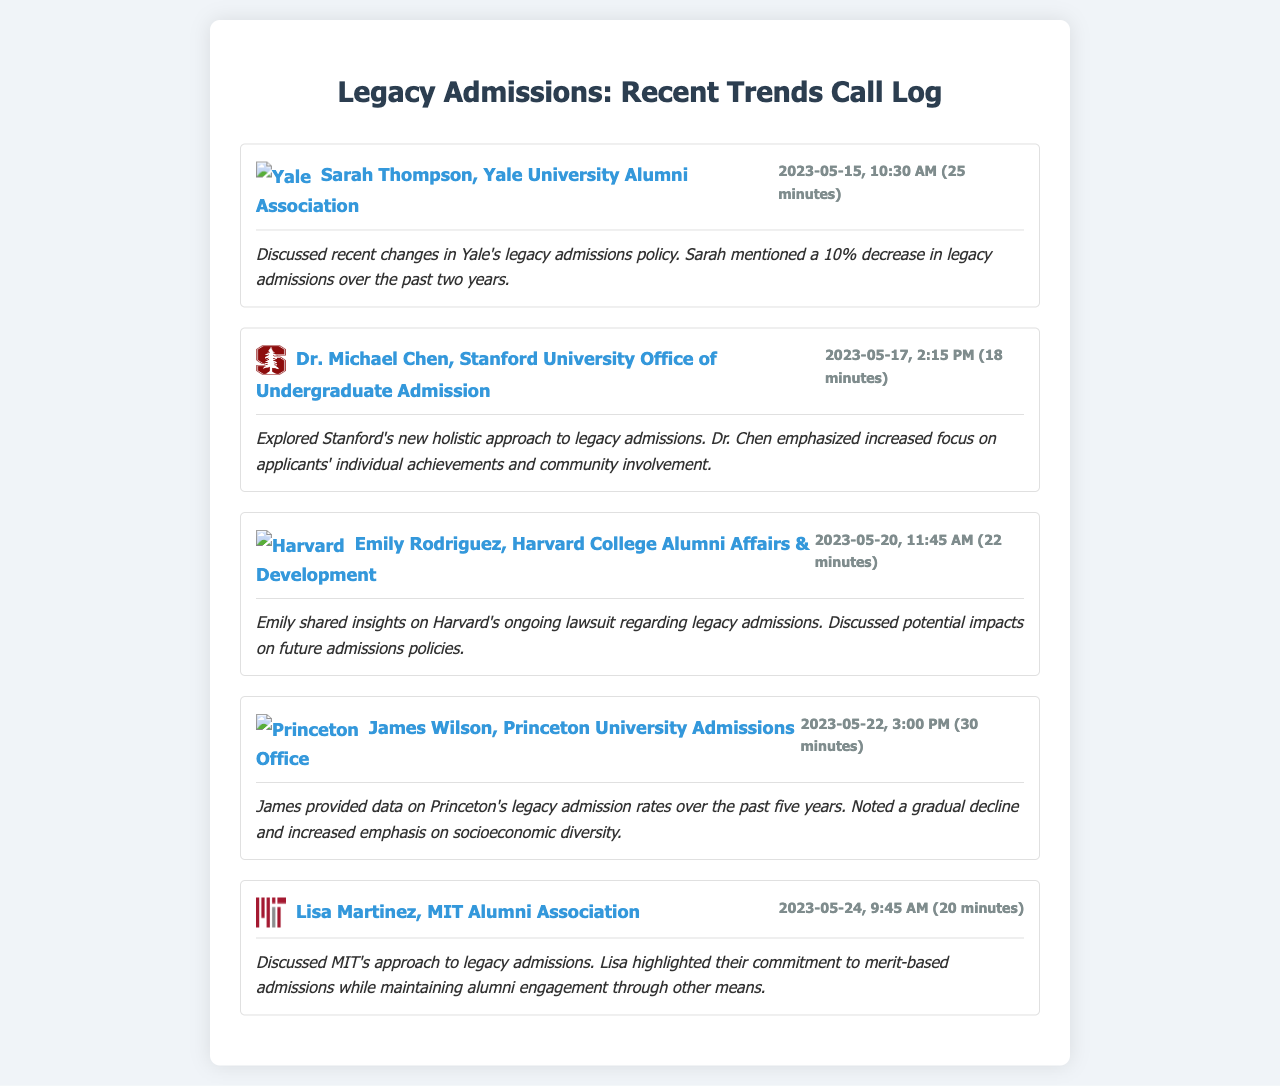What is the name of the first contact mentioned? The first contact listed is Sarah Thompson from the Yale University Alumni Association.
Answer: Sarah Thompson What university is associated with Dr. Michael Chen? Dr. Michael Chen works at Stanford University, as indicated in the call log.
Answer: Stanford University What was the date of the call with Emily Rodriguez? The call with Emily Rodriguez occurred on 2023-05-20.
Answer: 2023-05-20 How long was James Wilson's call? James Wilson's call lasted for 30 minutes.
Answer: 30 minutes What trend did Princeton's admissions office note? Princeton's admissions office noted a gradual decline in legacy admission rates.
Answer: Gradual decline What was discussed regarding Harvard's legacy admissions? Harvard's ongoing lawsuit regarding legacy admissions was discussed.
Answer: Ongoing lawsuit What is MIT's approach to legacy admissions? Lisa Martinez highlighted MIT's commitment to merit-based admissions.
Answer: Merit-based admissions On what date did Lisa Martinez have her call? Lisa Martinez's call took place on 2023-05-24.
Answer: 2023-05-24 What percentage decrease in legacy admissions did Yale mention? Yale mentioned a 10% decrease in legacy admissions over the past two years.
Answer: 10% decrease 